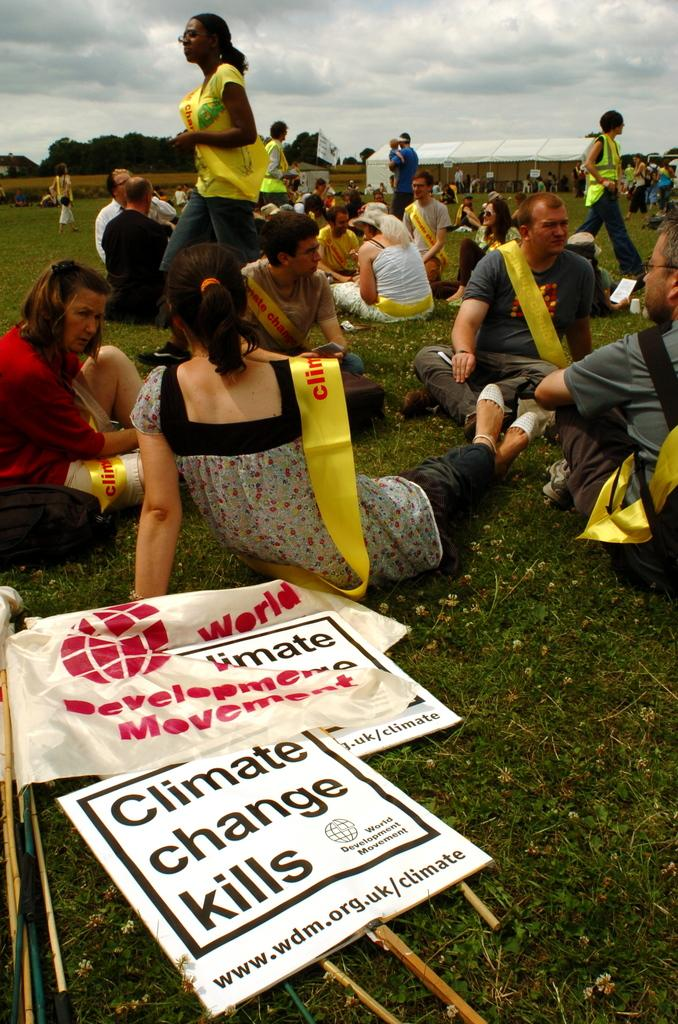Who or what is present in the image? There are people in the image. What are the people wearing? The people are wearing sashes. What can be seen in the background of the image? There are trees, boards, and flags in the background of the image. What is visible in the sky at the top of the image? There are clouds visible in the sky at the top of the image. Where is the kitty hiding in the image? There is no kitty present in the image. 